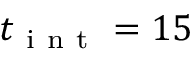Convert formula to latex. <formula><loc_0><loc_0><loc_500><loc_500>t _ { i n t } = 1 5</formula> 